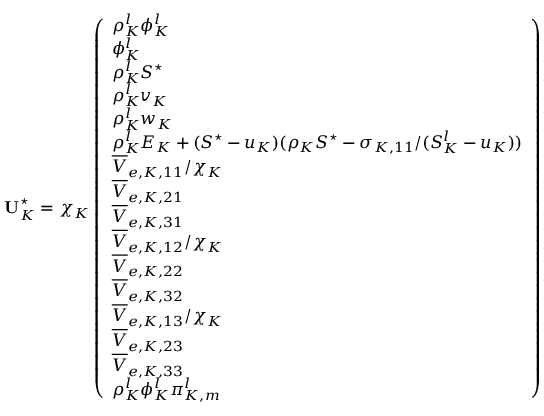Convert formula to latex. <formula><loc_0><loc_0><loc_500><loc_500>U _ { K } ^ { ^ { * } } = \chi _ { K } \left ( \begin{array} { l } { \rho _ { K } ^ { l } \phi _ { K } ^ { l } } \\ { \phi _ { K } ^ { l } } \\ { \rho _ { K } ^ { l } S ^ { ^ { * } } } \\ { \rho _ { K } ^ { l } v _ { K } } \\ { \rho _ { K } ^ { l } w _ { K } } \\ { \rho _ { K } ^ { l } E _ { K } + ( S ^ { ^ { * } } - u _ { K } ) ( \rho _ { K } S ^ { ^ { * } } - \sigma _ { K , 1 1 } / ( S _ { K } ^ { l } - u _ { K } ) ) } \\ { \overline { V } _ { e , K , 1 1 } / \chi _ { K } } \\ { \overline { V } _ { e , K , 2 1 } } \\ { \overline { V } _ { e , K , 3 1 } } \\ { \overline { V } _ { e , K , 1 2 } / \chi _ { K } } \\ { \overline { V } _ { e , K , 2 2 } } \\ { \overline { V } _ { e , K , 3 2 } } \\ { \overline { V } _ { e , K , 1 3 } / \chi _ { K } } \\ { \overline { V } _ { e , K , 2 3 } } \\ { \overline { V } _ { e , K , 3 3 } } \\ { \rho _ { K } ^ { l } \phi _ { K } ^ { l } \pi _ { K , m } ^ { l } } \end{array} \right )</formula> 